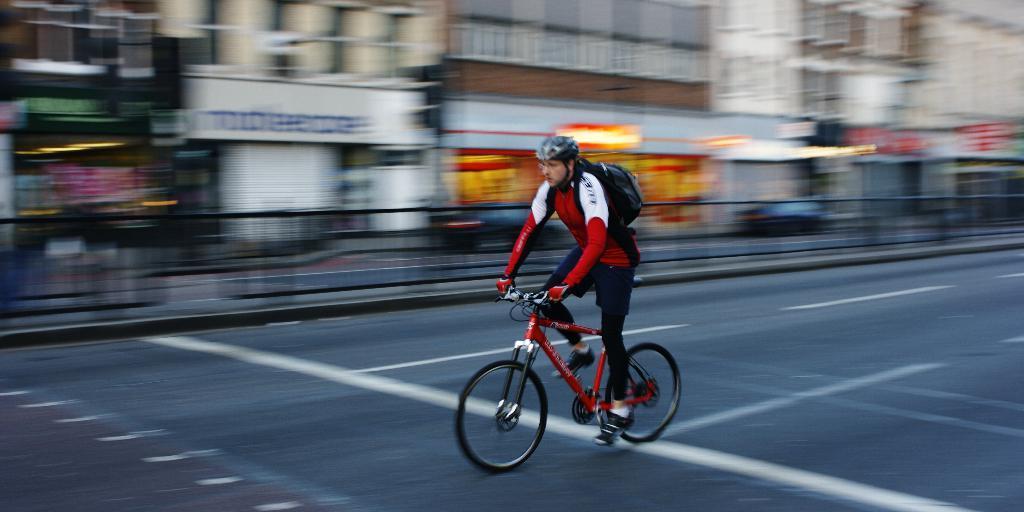Describe this image in one or two sentences. In this picture we can see a man wore a helmet and carrying a bag and riding a bicycle on the road and in the background we can see buildings, fence, some objects and it is blurry. 